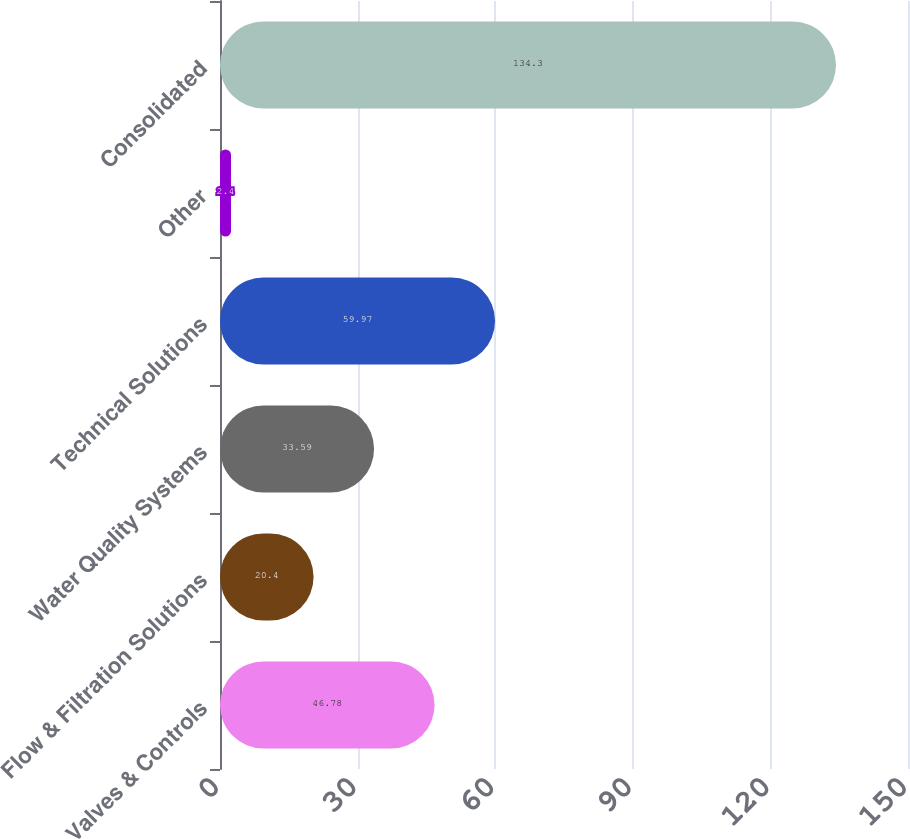Convert chart to OTSL. <chart><loc_0><loc_0><loc_500><loc_500><bar_chart><fcel>Valves & Controls<fcel>Flow & Filtration Solutions<fcel>Water Quality Systems<fcel>Technical Solutions<fcel>Other<fcel>Consolidated<nl><fcel>46.78<fcel>20.4<fcel>33.59<fcel>59.97<fcel>2.4<fcel>134.3<nl></chart> 